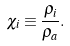Convert formula to latex. <formula><loc_0><loc_0><loc_500><loc_500>\chi _ { i } \equiv \frac { \rho _ { i } } { \rho _ { a } } .</formula> 